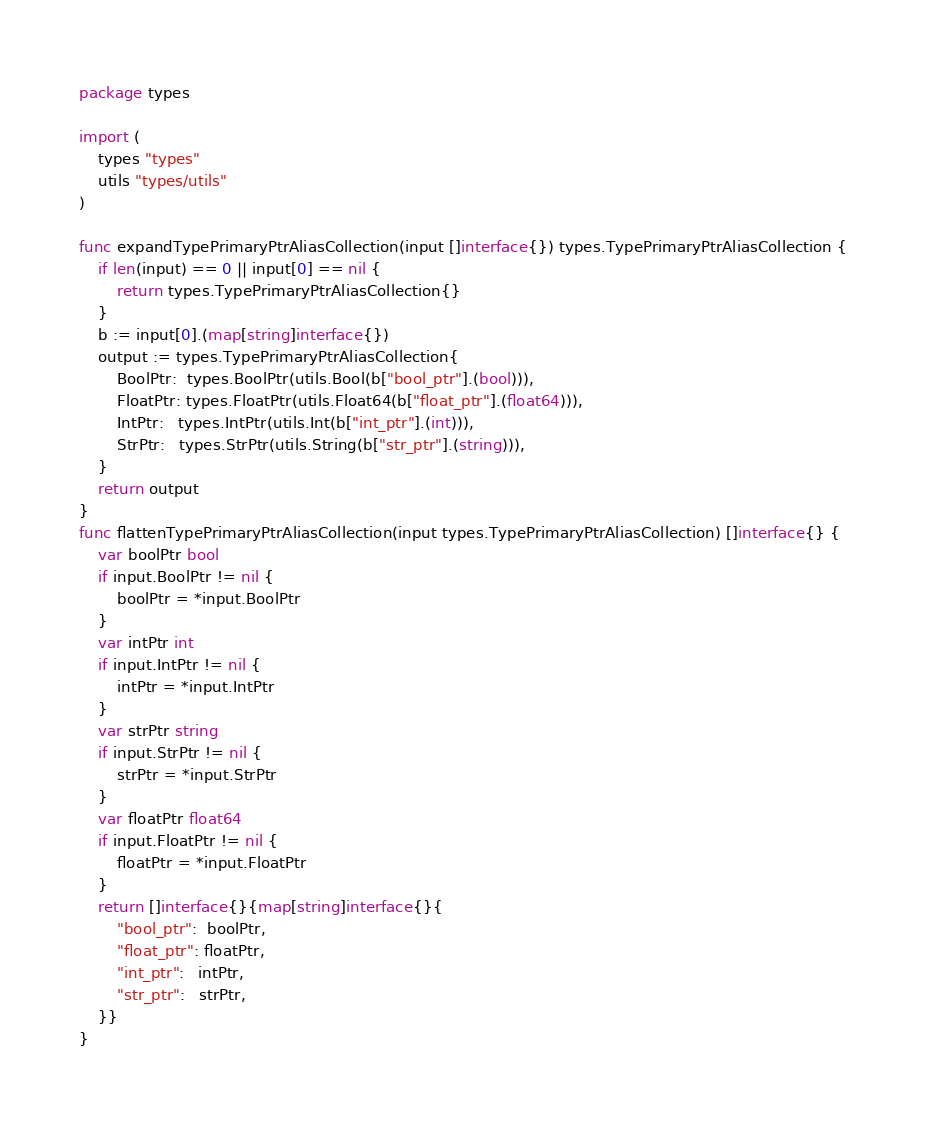Convert code to text. <code><loc_0><loc_0><loc_500><loc_500><_Go_>package types

import (
	types "types"
	utils "types/utils"
)

func expandTypePrimaryPtrAliasCollection(input []interface{}) types.TypePrimaryPtrAliasCollection {
	if len(input) == 0 || input[0] == nil {
		return types.TypePrimaryPtrAliasCollection{}
	}
	b := input[0].(map[string]interface{})
	output := types.TypePrimaryPtrAliasCollection{
		BoolPtr:  types.BoolPtr(utils.Bool(b["bool_ptr"].(bool))),
		FloatPtr: types.FloatPtr(utils.Float64(b["float_ptr"].(float64))),
		IntPtr:   types.IntPtr(utils.Int(b["int_ptr"].(int))),
		StrPtr:   types.StrPtr(utils.String(b["str_ptr"].(string))),
	}
	return output
}
func flattenTypePrimaryPtrAliasCollection(input types.TypePrimaryPtrAliasCollection) []interface{} {
	var boolPtr bool
	if input.BoolPtr != nil {
		boolPtr = *input.BoolPtr
	}
	var intPtr int
	if input.IntPtr != nil {
		intPtr = *input.IntPtr
	}
	var strPtr string
	if input.StrPtr != nil {
		strPtr = *input.StrPtr
	}
	var floatPtr float64
	if input.FloatPtr != nil {
		floatPtr = *input.FloatPtr
	}
	return []interface{}{map[string]interface{}{
		"bool_ptr":  boolPtr,
		"float_ptr": floatPtr,
		"int_ptr":   intPtr,
		"str_ptr":   strPtr,
	}}
}
</code> 